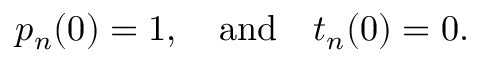<formula> <loc_0><loc_0><loc_500><loc_500>p _ { n } ( 0 ) = 1 , \quad a n d \quad t _ { n } ( 0 ) = 0 .</formula> 